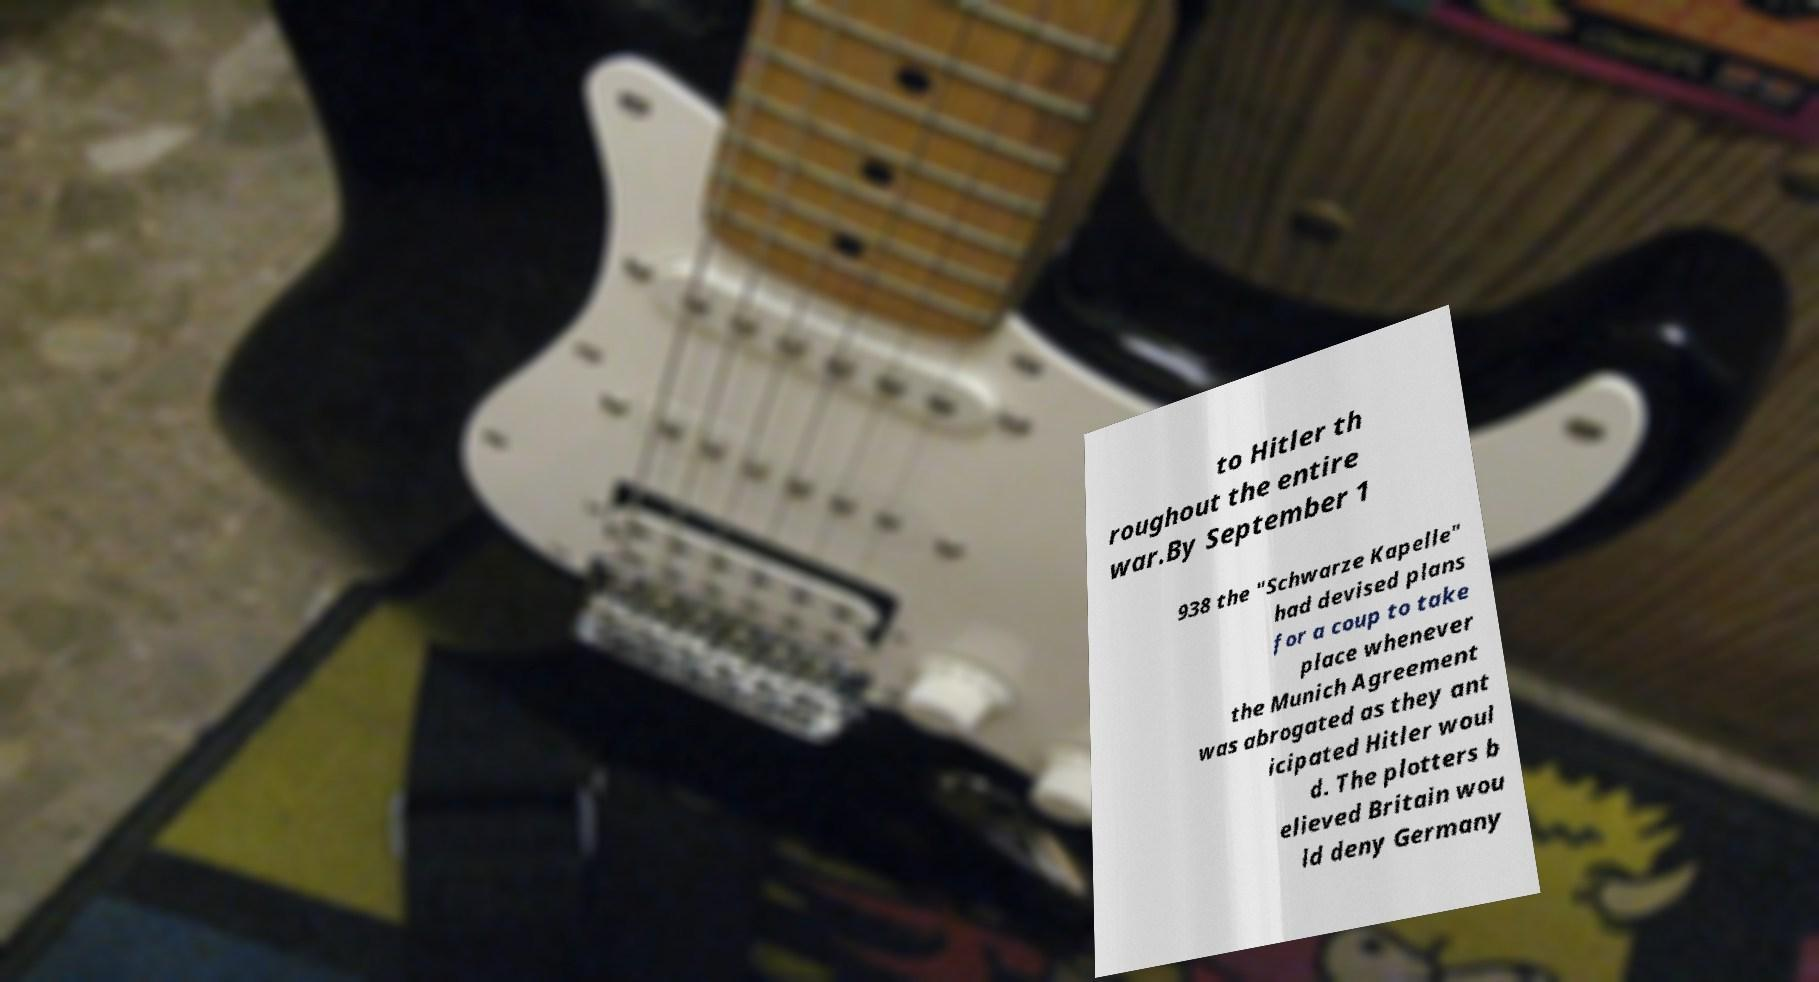Could you extract and type out the text from this image? to Hitler th roughout the entire war.By September 1 938 the "Schwarze Kapelle" had devised plans for a coup to take place whenever the Munich Agreement was abrogated as they ant icipated Hitler woul d. The plotters b elieved Britain wou ld deny Germany 